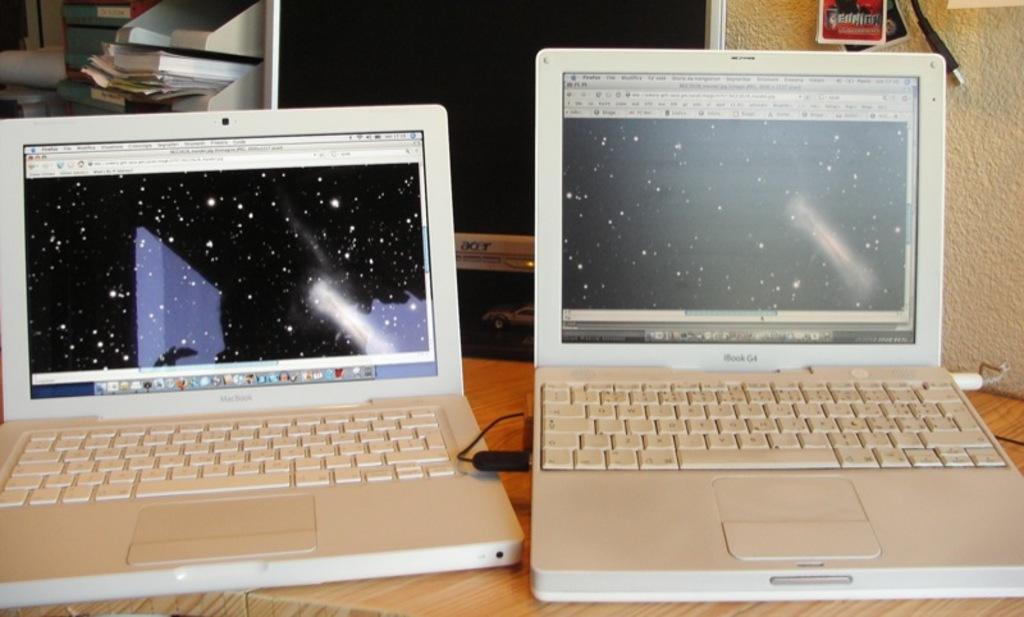Describe this image in one or two sentences. In this image I can see a two laptop. They are in white color. Laptop is on the table. Back I can see papers,screen and some objects. The wall is in cream color. 